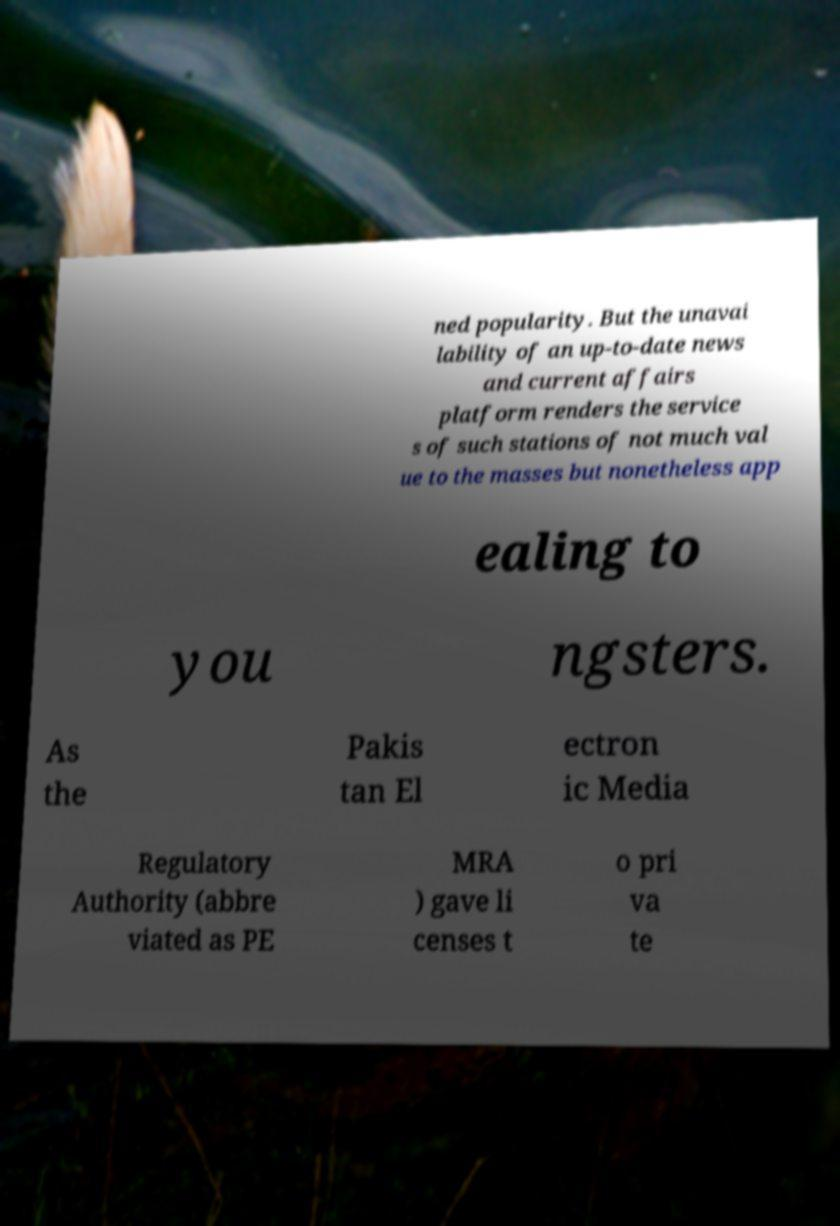Could you assist in decoding the text presented in this image and type it out clearly? ned popularity. But the unavai lability of an up-to-date news and current affairs platform renders the service s of such stations of not much val ue to the masses but nonetheless app ealing to you ngsters. As the Pakis tan El ectron ic Media Regulatory Authority (abbre viated as PE MRA ) gave li censes t o pri va te 